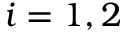Convert formula to latex. <formula><loc_0><loc_0><loc_500><loc_500>i = 1 , 2</formula> 